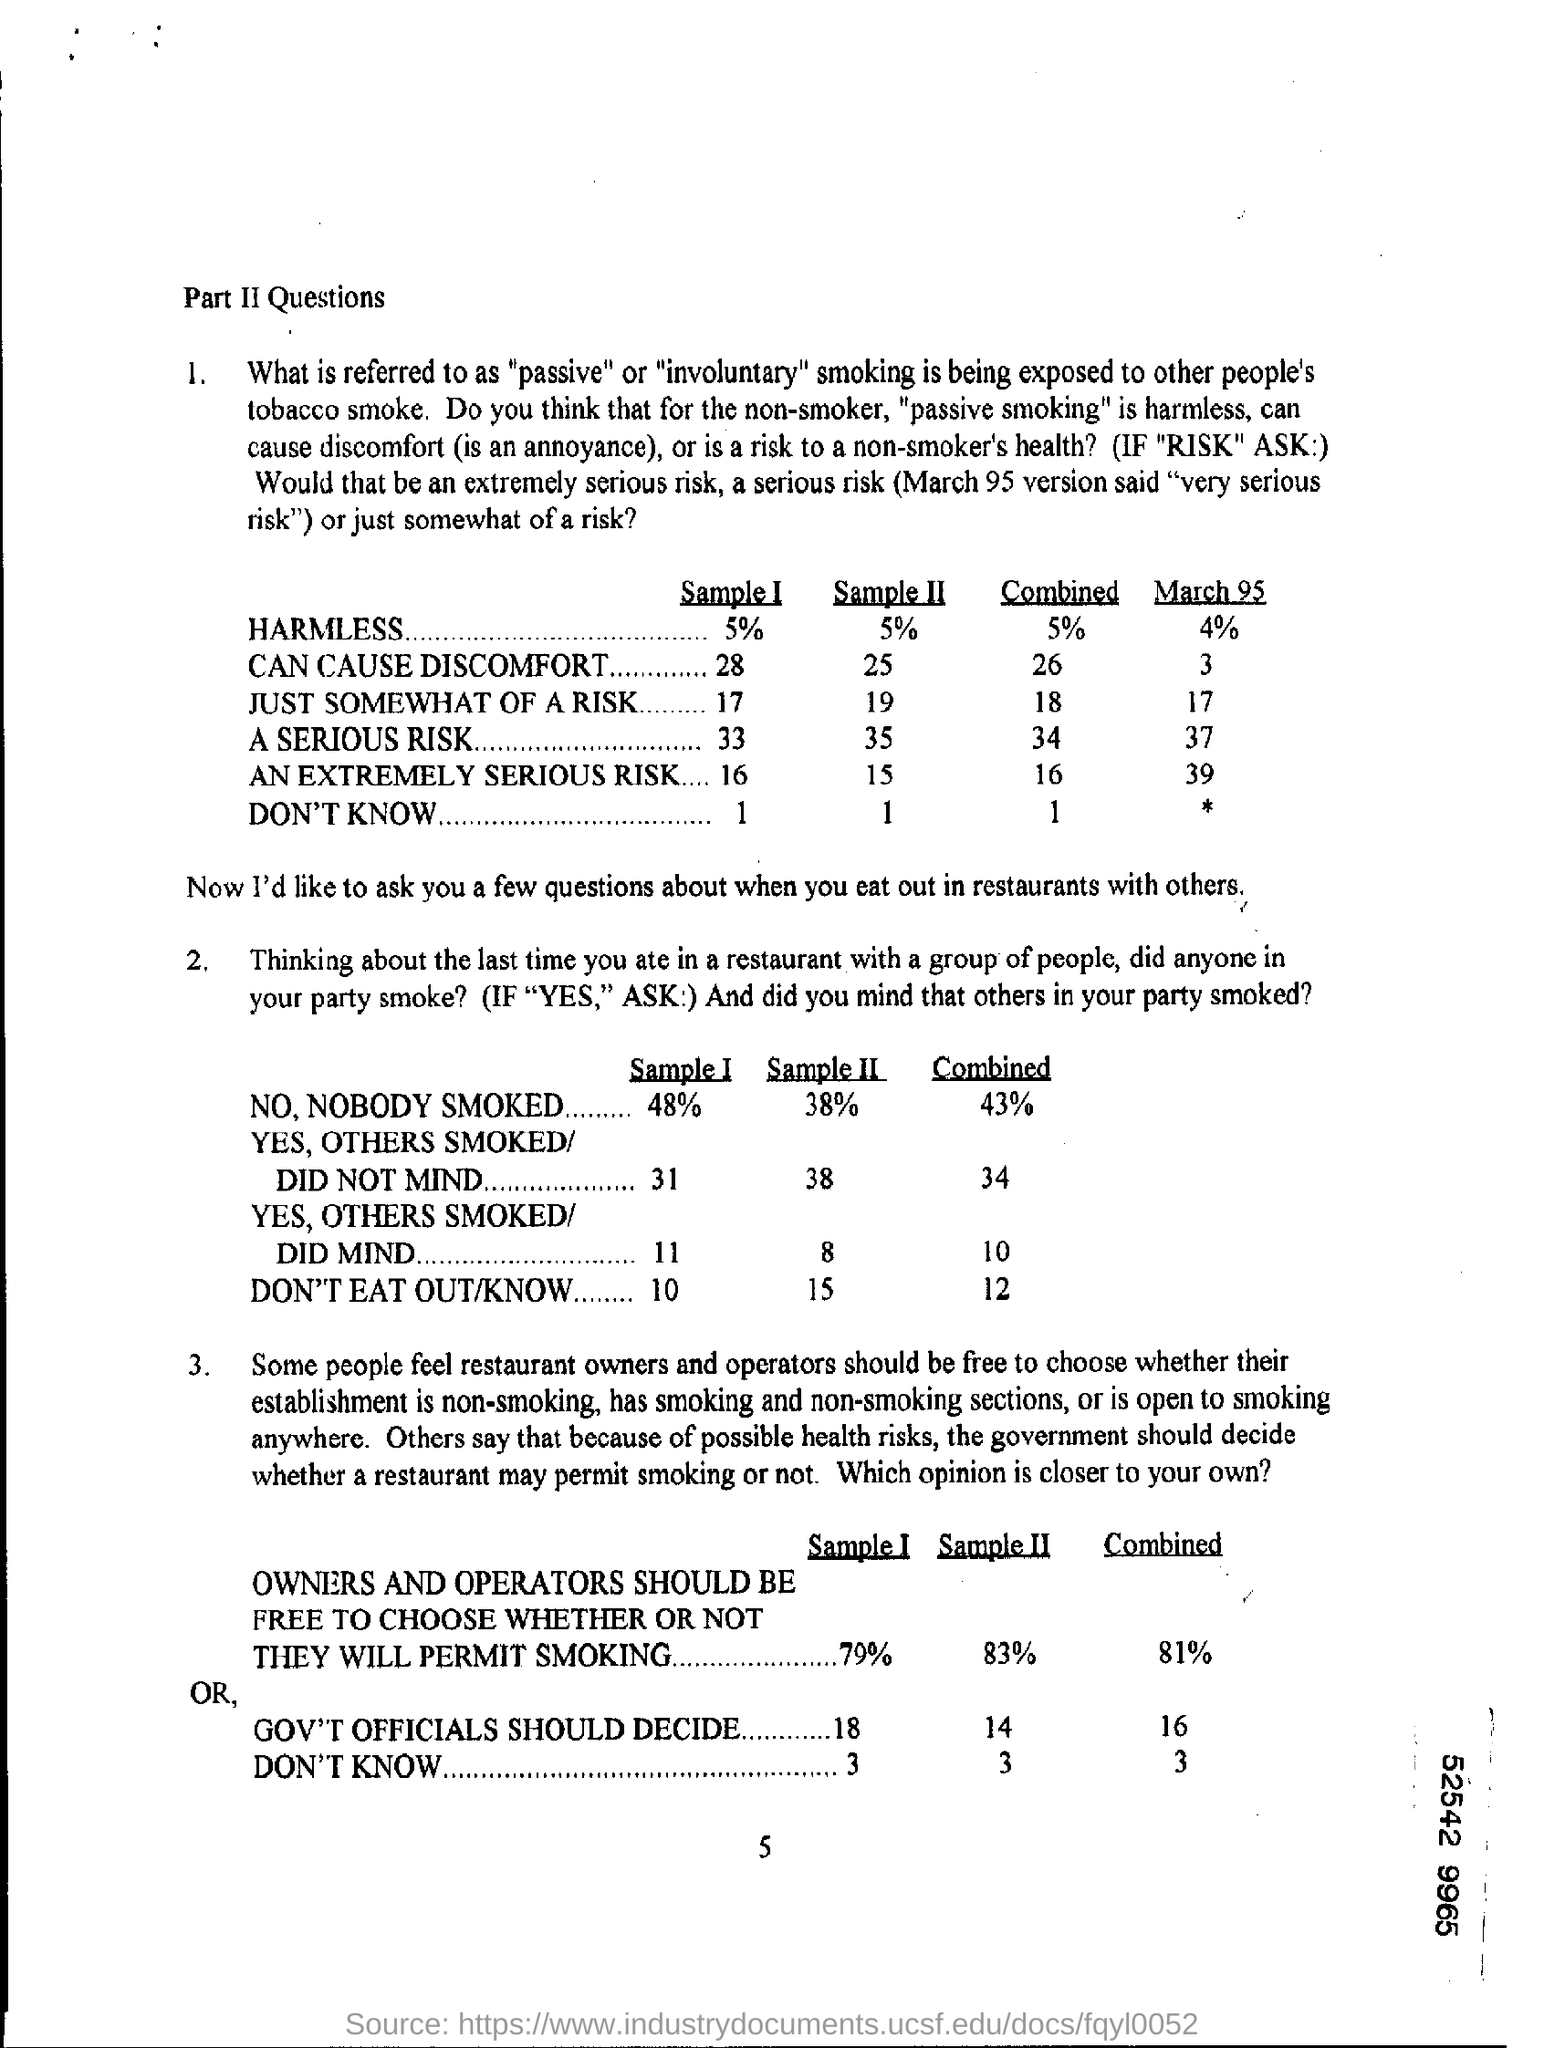What is the number at bottom of the page ?
Offer a terse response. 5. How much is the % of harmless in sample i?
Provide a succinct answer. 5%. 